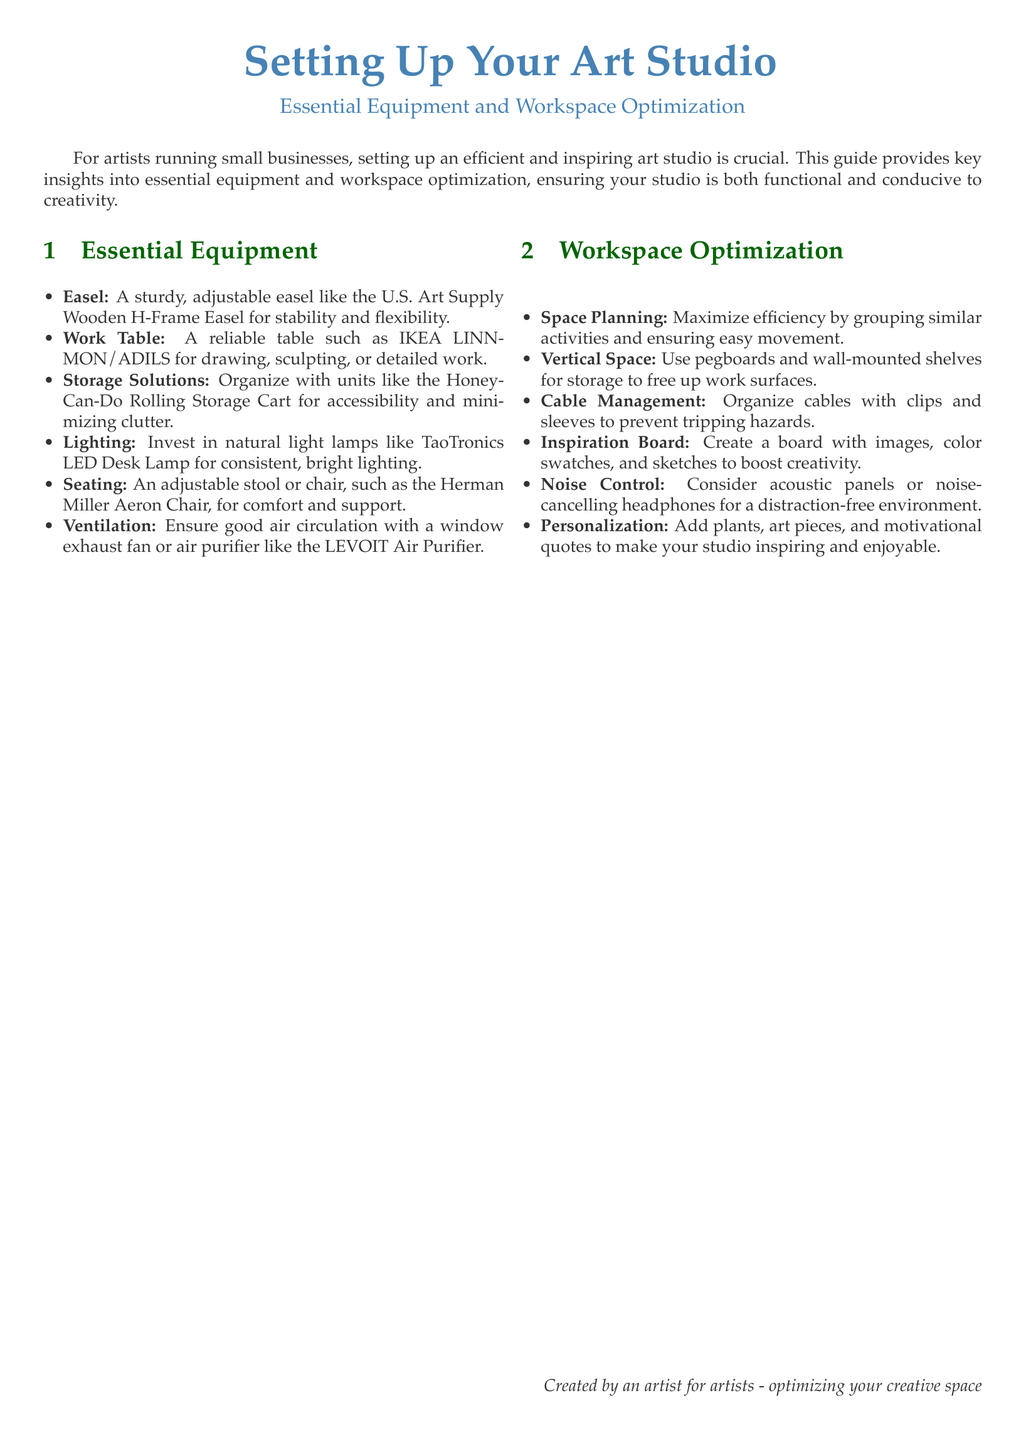What is the title of the document? The title is the bold heading provided at the top, which identifies the main topic of the guide.
Answer: Setting Up Your Art Studio What equipment is suggested for lighting? The section on essential equipment includes recommendations for lighting to ensure adequate visibility in the workspace.
Answer: TaoTronics LED Desk Lamp Which storage solution is mentioned? The guide recommends specific items for organizing the workspace to maintain a clutter-free environment.
Answer: Honey-Can-Do Rolling Storage Cart What is an example of a seating option? The document lists various types of essential equipment, including suggestions for comfortable seating.
Answer: Herman Miller Aeron Chair What is one way to optimize workspace organization? The document provides tips on how to efficiently arrange the workspace for better functionality and creativity.
Answer: Use pegboards and wall-mounted shelves How can an artist enhance inspiration in their studio? Document mentions methods to boost creativity and motivation within the workspace.
Answer: Create a board with images, color swatches, and sketches What is the purpose of the document? The introductory text outlines the aim of the guide for the target audience.
Answer: Optimizing your creative space What is suggested for noise control? This recommendation is included in the workspace optimization section to reduce distractions while working.
Answer: Acoustic panels or noise-cancelling headphones 